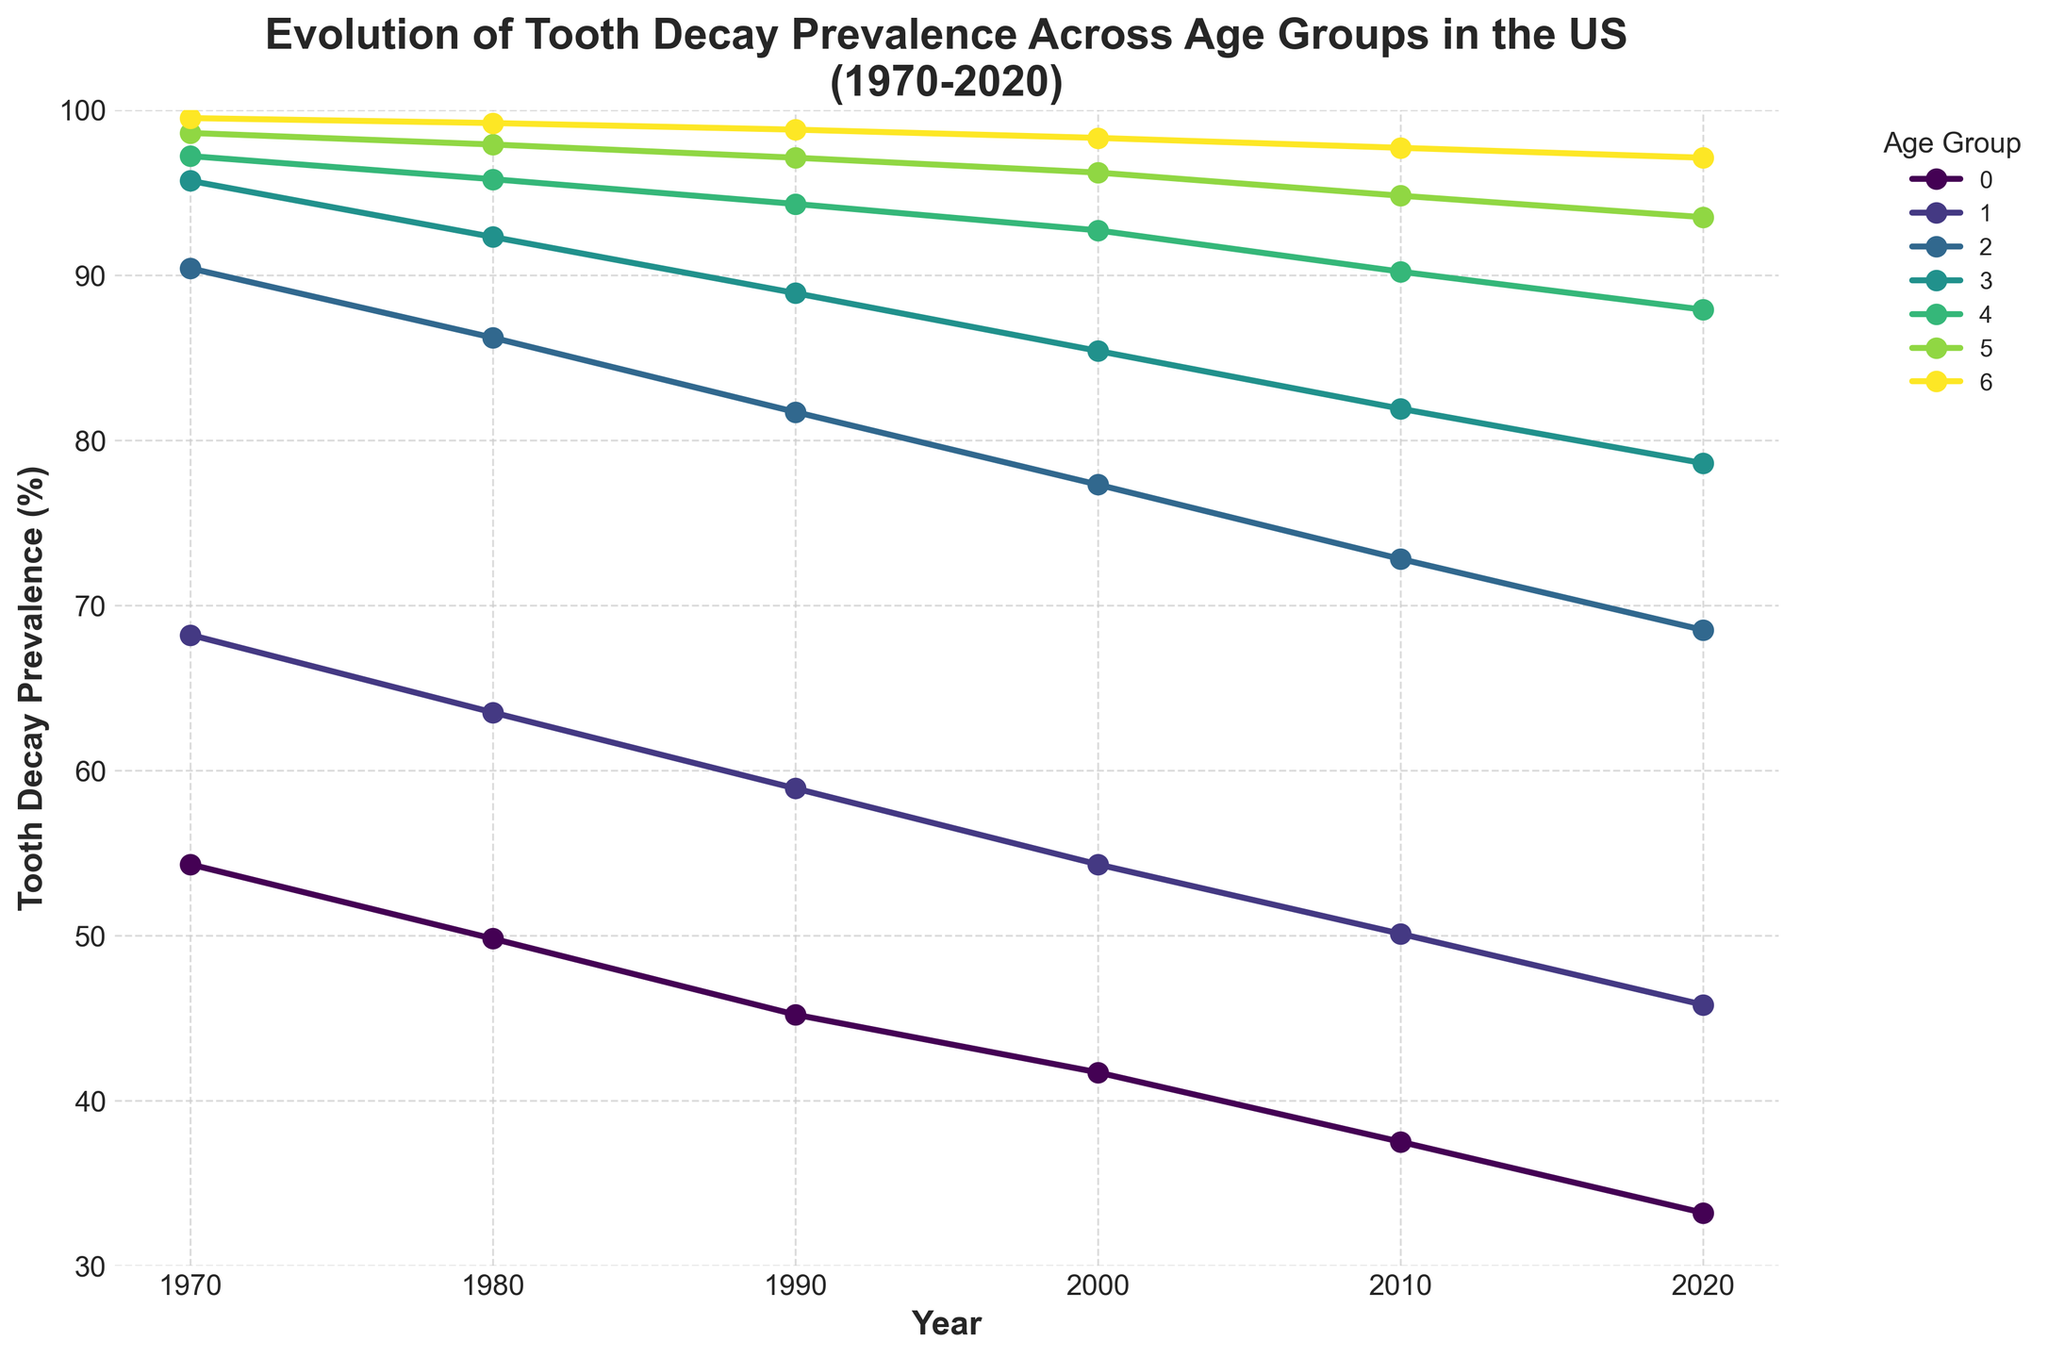What is the overall trend in tooth decay prevalence for the age group 2-5 years from 1970 to 2020? The line chart shows a consistent decline in tooth decay prevalence for the age group 2-5 years from 1970 to 2020, starting at 54.3% in 1970 and decreasing to 33.2% in 2020.
Answer: Decline Which age group experienced the smallest decrease in tooth decay prevalence from 1970 to 2020? By comparing all the age groups' data, the 65+ years age group shows the smallest decrease, from 99.5% in 1970 to 97.1% in 2020, a difference of 2.4%.
Answer: 65+ years Between the years 2000 and 2020, which age group had the most significant reduction in tooth decay prevalence? By visually inspecting the change from 2000 to 2020 for all age groups, the age group 2-5 years decreased from 41.7% to 33.2%, a reduction of 8.5%, the largest among all groups.
Answer: 2-5 years Which age group had the highest tooth decay prevalence in the year 1980? Looking at the plot for the year 1980, the age group 65+ years had the highest prevalence of 99.2%.
Answer: 65+ years How much did the tooth decay prevalence for the 35-49 years age group change over the 50-year period from 1970 to 2020? The data shows a decrease from 97.2% in 1970 to 87.9% in 2020, giving a change of 97.2 - 87.9 = 9.3%.
Answer: 9.3% What is the average tooth decay prevalence for the 6-11 years age group across all recorded years? The values for 6-11 years group are 68.2, 63.5, 58.9, 54.3, 50.1, and 45.8. Summing these up gives 340.8, and dividing by 6 gives an average of 340.8 / 6 ≈ 56.8%.
Answer: 56.8% In the year 1990, which two age groups had the closest tooth decay prevalence? From the plot, in 1990, the age groups 12-19 years and 20-34 years had prevalences of 81.7% and 88.9%, respectively, giving a difference of 88.9 - 81.7 = 7.2%, which is the smallest among the combinations.
Answer: 12-19 years and 20-34 years What is the combined tooth decay prevalence for all age groups in the year 2000? Adding the values for all age groups in 2000: 41.7 + 54.3 + 77.3 + 85.4 + 92.7 + 96.2 + 98.3 = 545.9%.
Answer: 545.9% Between 1970 and 2020, which age group experienced the highest initial tooth decay prevalence and what was its value? The age group 65+ years had the highest initial tooth decay prevalence at 99.5% in 1970.
Answer: 99.5% 